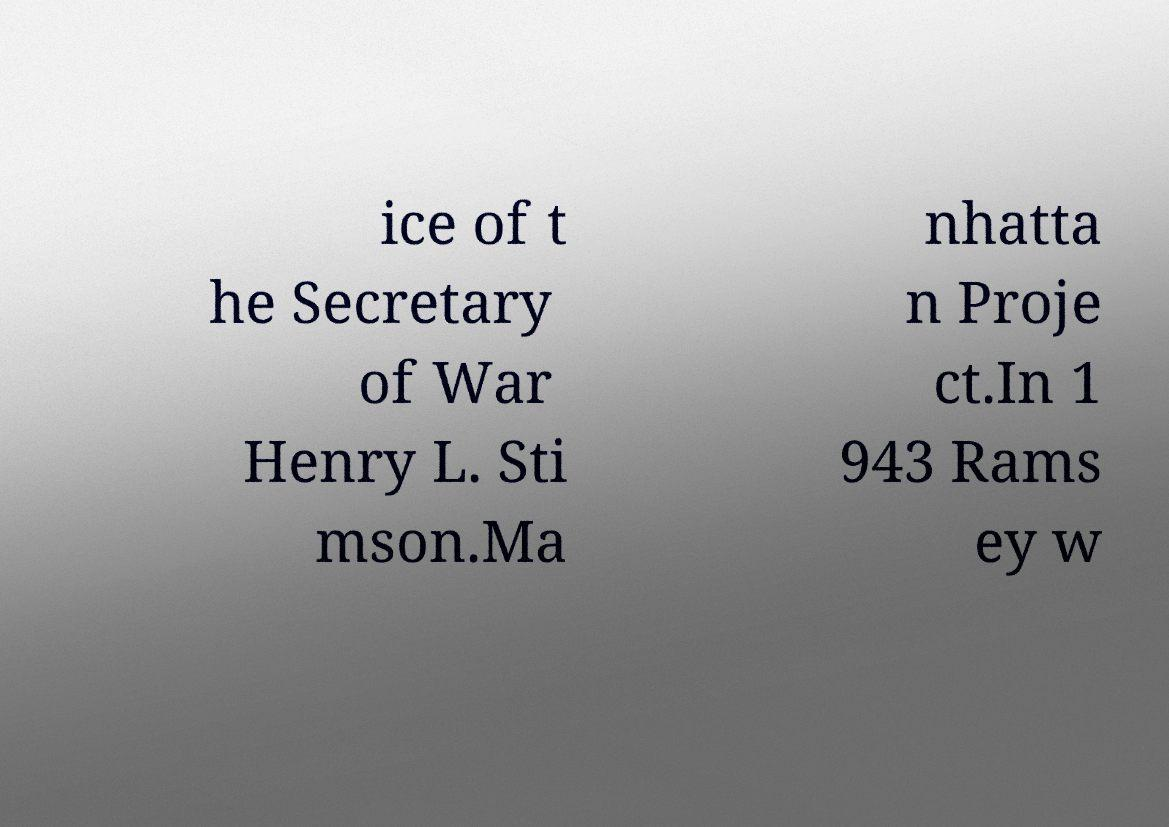Could you extract and type out the text from this image? ice of t he Secretary of War Henry L. Sti mson.Ma nhatta n Proje ct.In 1 943 Rams ey w 